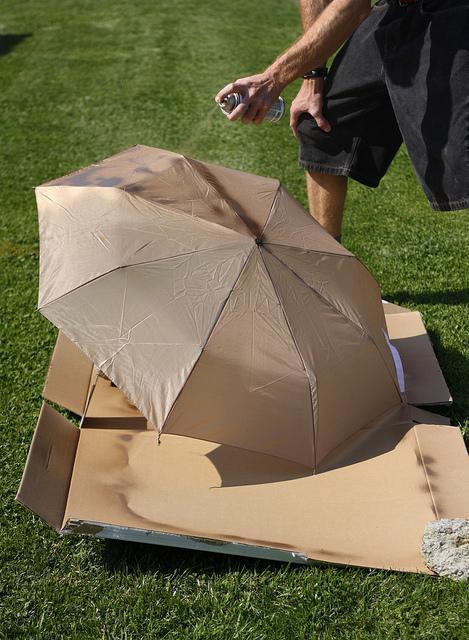Is "The person is beneath the umbrella." an appropriate description for the image?
Answer yes or no. No. Is the statement "The umbrella is above the person." accurate regarding the image?
Answer yes or no. No. 